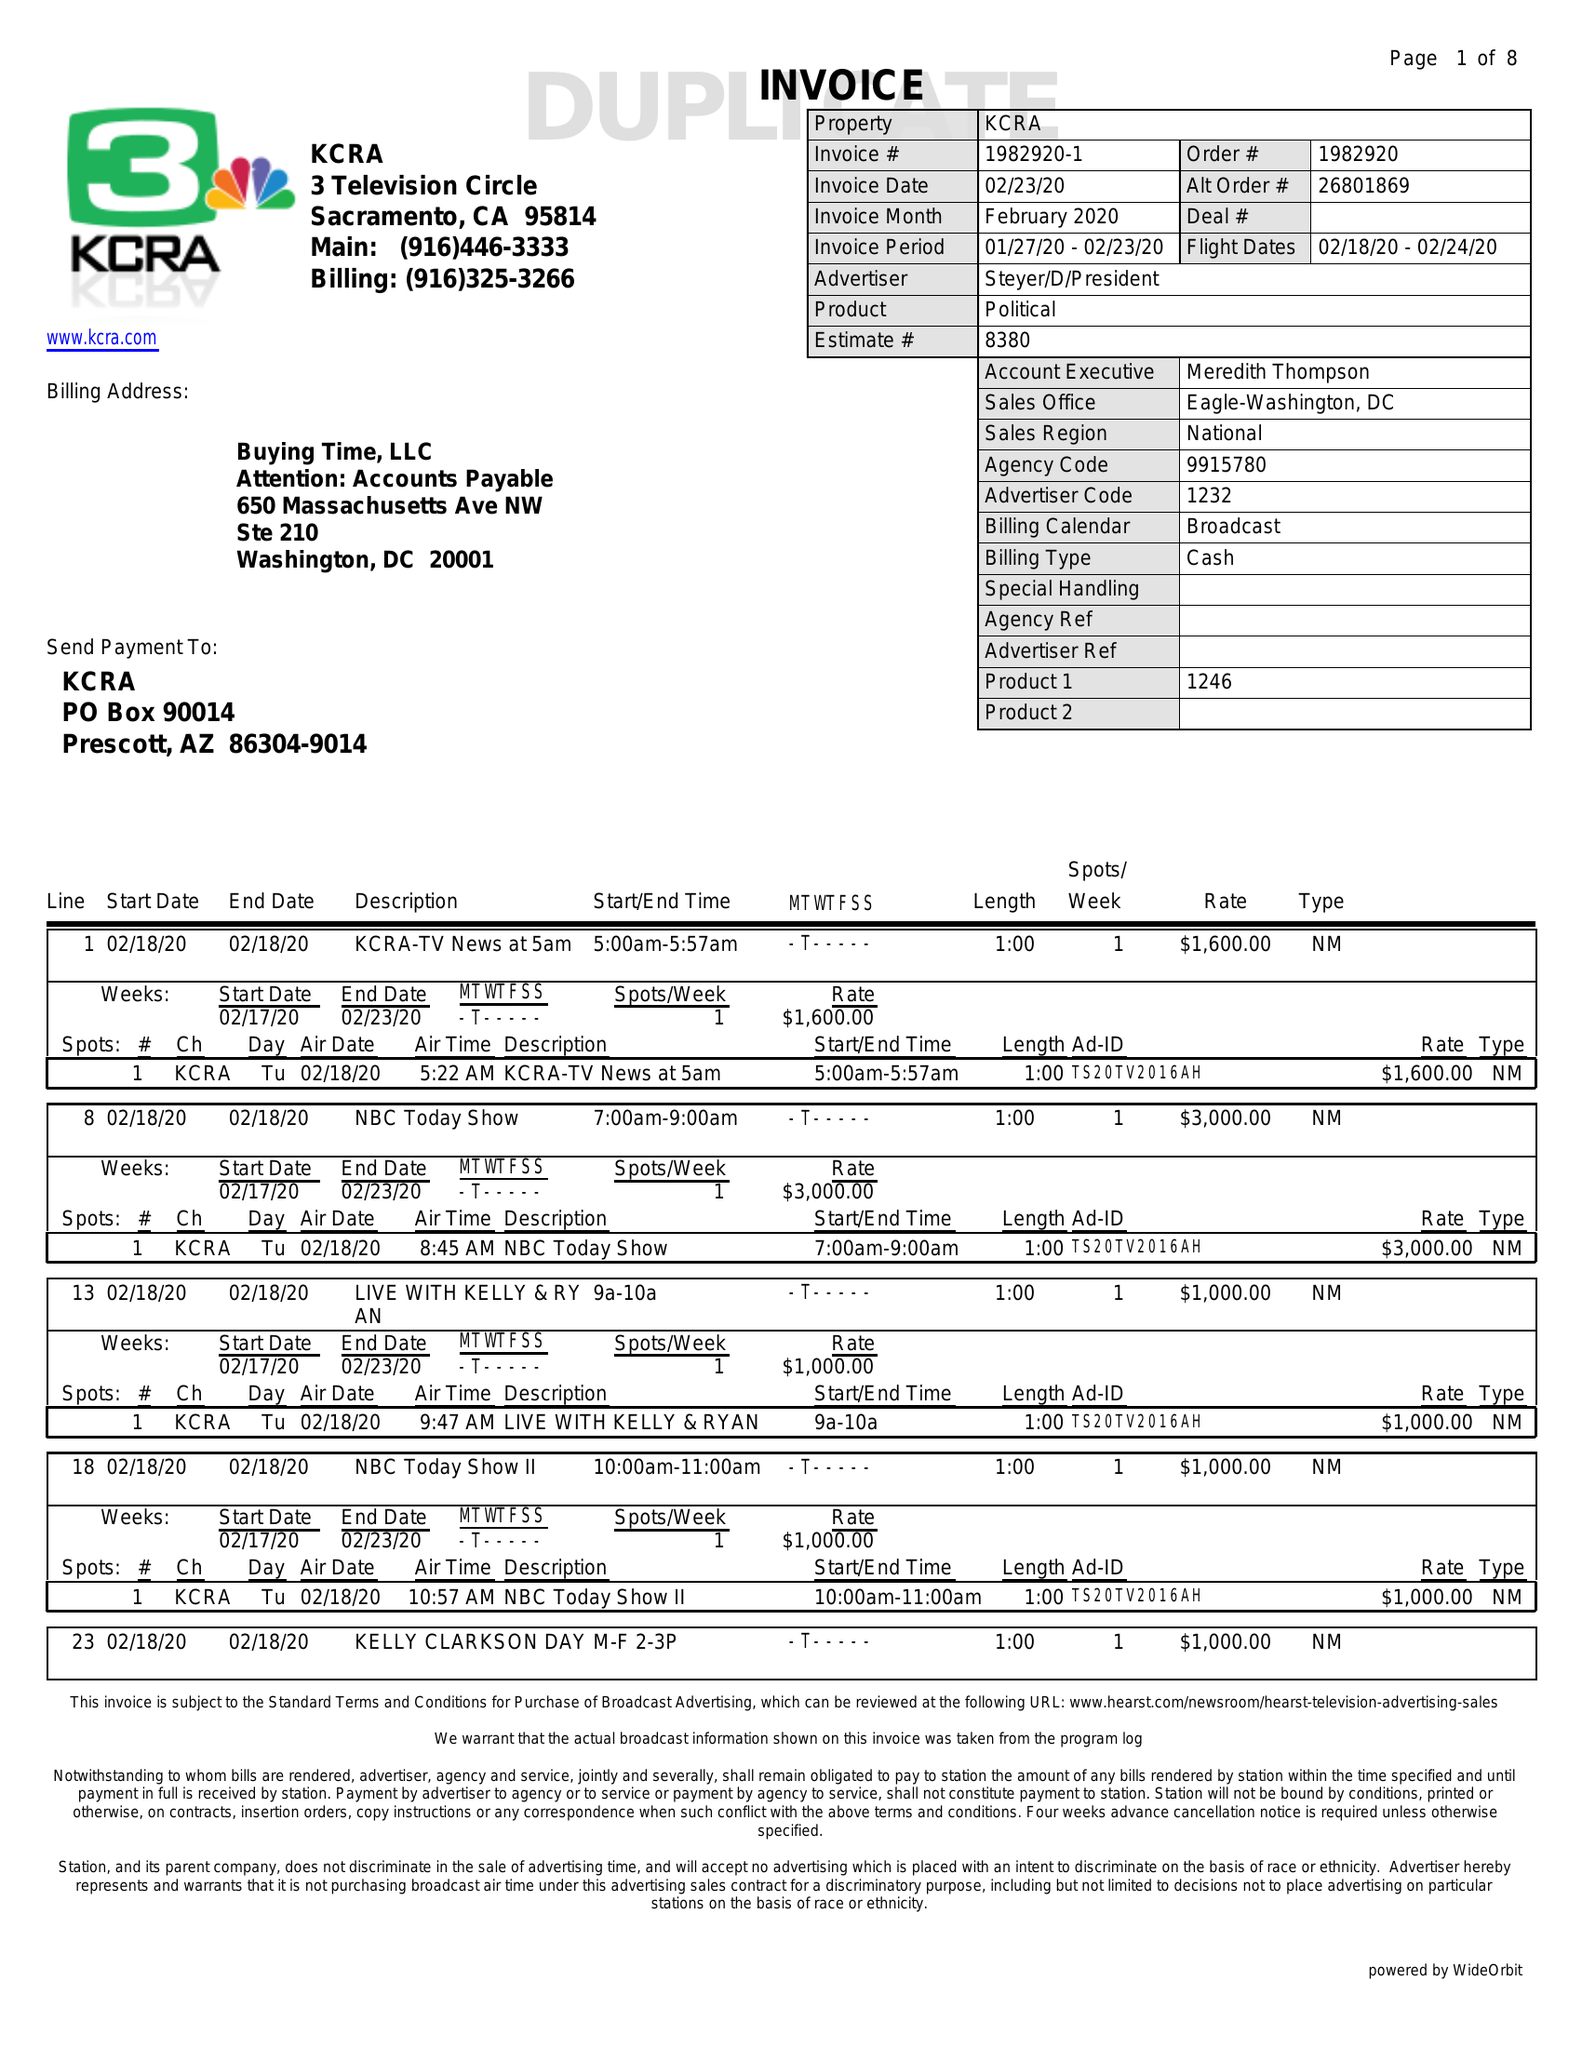What is the value for the contract_num?
Answer the question using a single word or phrase. 1982920 